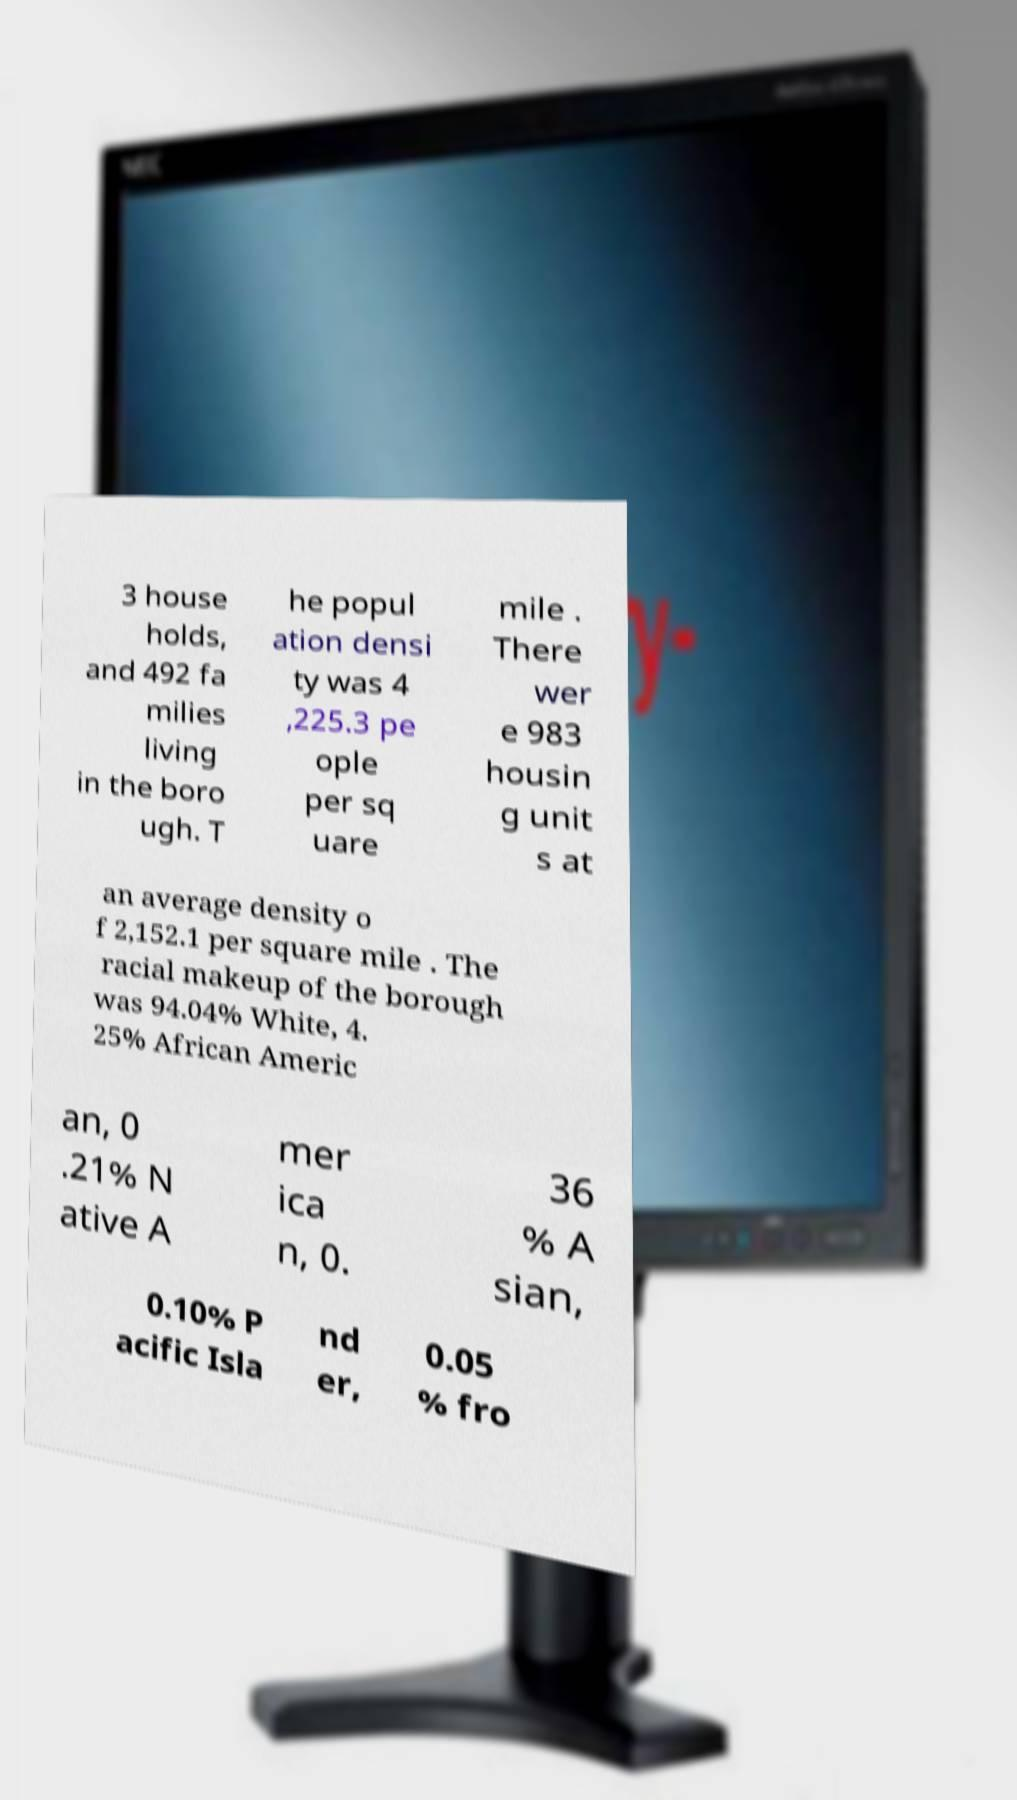Could you extract and type out the text from this image? 3 house holds, and 492 fa milies living in the boro ugh. T he popul ation densi ty was 4 ,225.3 pe ople per sq uare mile . There wer e 983 housin g unit s at an average density o f 2,152.1 per square mile . The racial makeup of the borough was 94.04% White, 4. 25% African Americ an, 0 .21% N ative A mer ica n, 0. 36 % A sian, 0.10% P acific Isla nd er, 0.05 % fro 